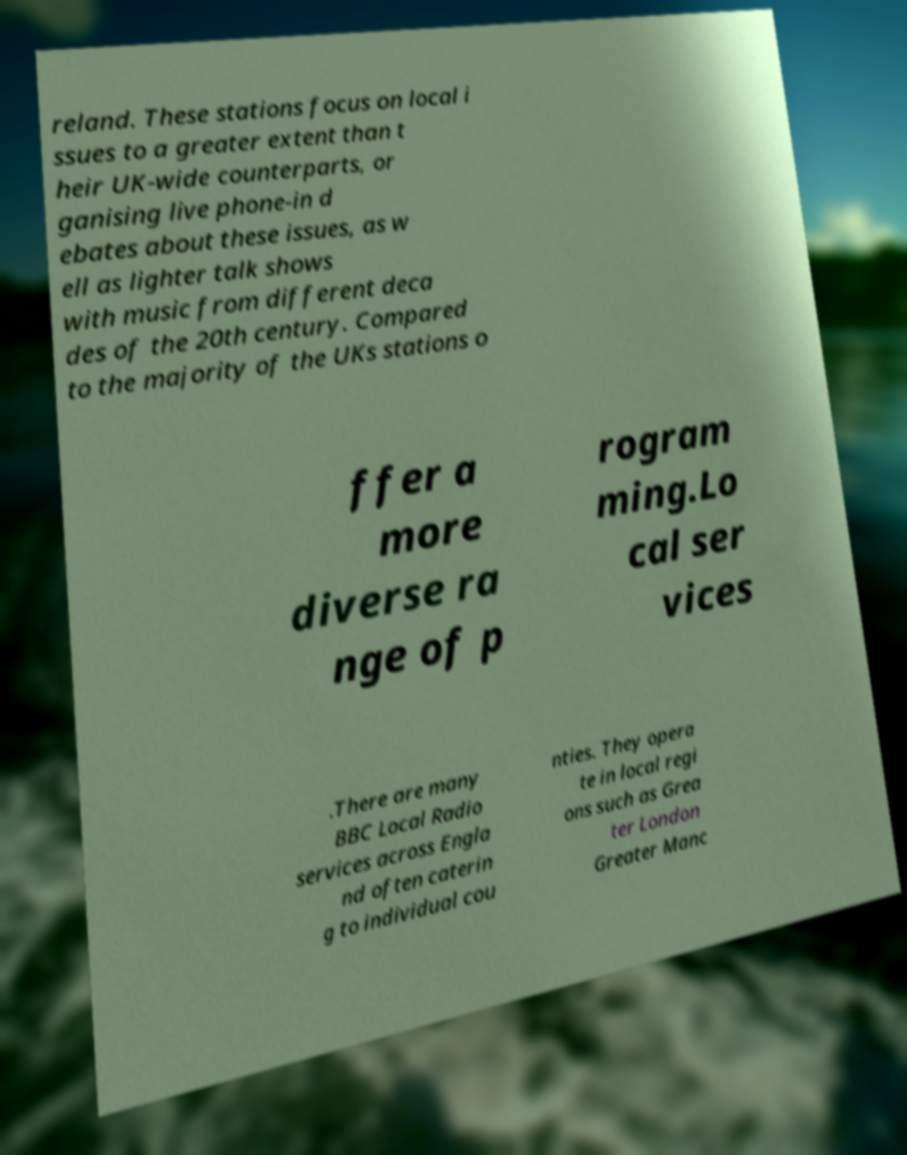Please identify and transcribe the text found in this image. reland. These stations focus on local i ssues to a greater extent than t heir UK-wide counterparts, or ganising live phone-in d ebates about these issues, as w ell as lighter talk shows with music from different deca des of the 20th century. Compared to the majority of the UKs stations o ffer a more diverse ra nge of p rogram ming.Lo cal ser vices .There are many BBC Local Radio services across Engla nd often caterin g to individual cou nties. They opera te in local regi ons such as Grea ter London Greater Manc 